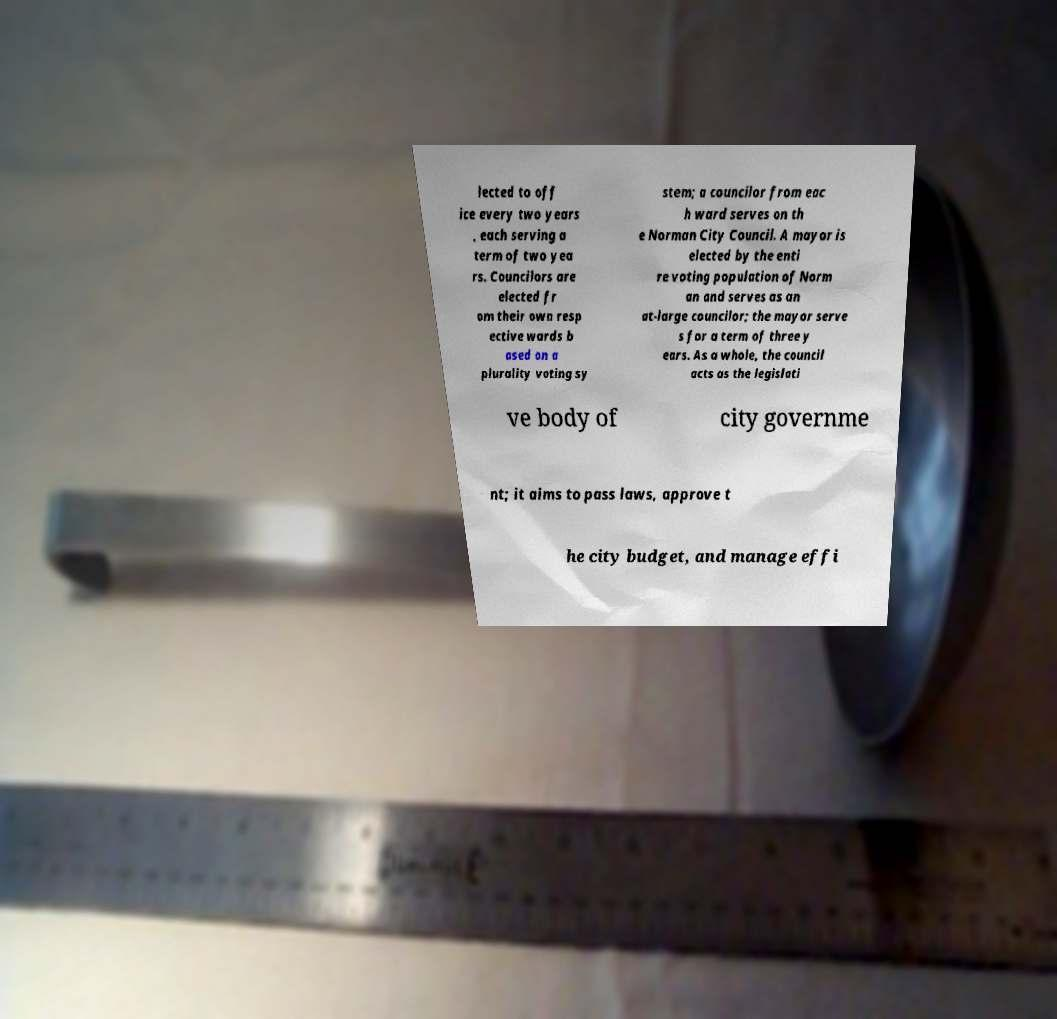What messages or text are displayed in this image? I need them in a readable, typed format. lected to off ice every two years , each serving a term of two yea rs. Councilors are elected fr om their own resp ective wards b ased on a plurality voting sy stem; a councilor from eac h ward serves on th e Norman City Council. A mayor is elected by the enti re voting population of Norm an and serves as an at-large councilor; the mayor serve s for a term of three y ears. As a whole, the council acts as the legislati ve body of city governme nt; it aims to pass laws, approve t he city budget, and manage effi 